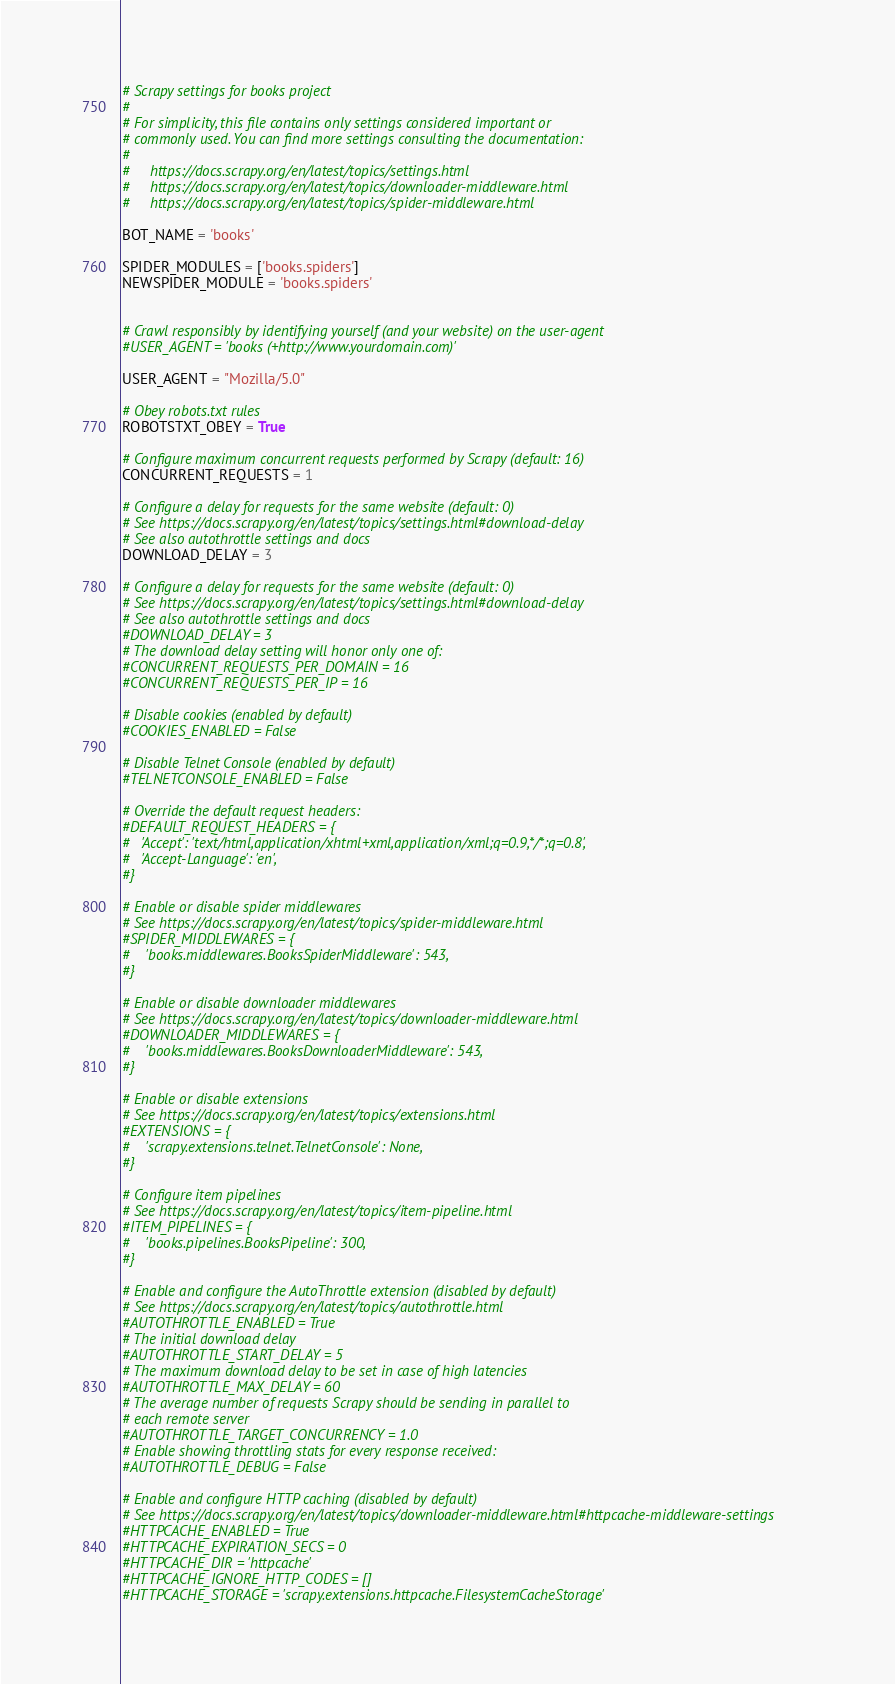<code> <loc_0><loc_0><loc_500><loc_500><_Python_># Scrapy settings for books project
#
# For simplicity, this file contains only settings considered important or
# commonly used. You can find more settings consulting the documentation:
#
#     https://docs.scrapy.org/en/latest/topics/settings.html
#     https://docs.scrapy.org/en/latest/topics/downloader-middleware.html
#     https://docs.scrapy.org/en/latest/topics/spider-middleware.html

BOT_NAME = 'books'

SPIDER_MODULES = ['books.spiders']
NEWSPIDER_MODULE = 'books.spiders'


# Crawl responsibly by identifying yourself (and your website) on the user-agent
#USER_AGENT = 'books (+http://www.yourdomain.com)'

USER_AGENT = "Mozilla/5.0"

# Obey robots.txt rules
ROBOTSTXT_OBEY = True

# Configure maximum concurrent requests performed by Scrapy (default: 16)
CONCURRENT_REQUESTS = 1

# Configure a delay for requests for the same website (default: 0)
# See https://docs.scrapy.org/en/latest/topics/settings.html#download-delay
# See also autothrottle settings and docs
DOWNLOAD_DELAY = 3

# Configure a delay for requests for the same website (default: 0)
# See https://docs.scrapy.org/en/latest/topics/settings.html#download-delay
# See also autothrottle settings and docs
#DOWNLOAD_DELAY = 3
# The download delay setting will honor only one of:
#CONCURRENT_REQUESTS_PER_DOMAIN = 16
#CONCURRENT_REQUESTS_PER_IP = 16

# Disable cookies (enabled by default)
#COOKIES_ENABLED = False

# Disable Telnet Console (enabled by default)
#TELNETCONSOLE_ENABLED = False

# Override the default request headers:
#DEFAULT_REQUEST_HEADERS = {
#   'Accept': 'text/html,application/xhtml+xml,application/xml;q=0.9,*/*;q=0.8',
#   'Accept-Language': 'en',
#}

# Enable or disable spider middlewares
# See https://docs.scrapy.org/en/latest/topics/spider-middleware.html
#SPIDER_MIDDLEWARES = {
#    'books.middlewares.BooksSpiderMiddleware': 543,
#}

# Enable or disable downloader middlewares
# See https://docs.scrapy.org/en/latest/topics/downloader-middleware.html
#DOWNLOADER_MIDDLEWARES = {
#    'books.middlewares.BooksDownloaderMiddleware': 543,
#}

# Enable or disable extensions
# See https://docs.scrapy.org/en/latest/topics/extensions.html
#EXTENSIONS = {
#    'scrapy.extensions.telnet.TelnetConsole': None,
#}

# Configure item pipelines
# See https://docs.scrapy.org/en/latest/topics/item-pipeline.html
#ITEM_PIPELINES = {
#    'books.pipelines.BooksPipeline': 300,
#}

# Enable and configure the AutoThrottle extension (disabled by default)
# See https://docs.scrapy.org/en/latest/topics/autothrottle.html
#AUTOTHROTTLE_ENABLED = True
# The initial download delay
#AUTOTHROTTLE_START_DELAY = 5
# The maximum download delay to be set in case of high latencies
#AUTOTHROTTLE_MAX_DELAY = 60
# The average number of requests Scrapy should be sending in parallel to
# each remote server
#AUTOTHROTTLE_TARGET_CONCURRENCY = 1.0
# Enable showing throttling stats for every response received:
#AUTOTHROTTLE_DEBUG = False

# Enable and configure HTTP caching (disabled by default)
# See https://docs.scrapy.org/en/latest/topics/downloader-middleware.html#httpcache-middleware-settings
#HTTPCACHE_ENABLED = True
#HTTPCACHE_EXPIRATION_SECS = 0
#HTTPCACHE_DIR = 'httpcache'
#HTTPCACHE_IGNORE_HTTP_CODES = []
#HTTPCACHE_STORAGE = 'scrapy.extensions.httpcache.FilesystemCacheStorage'
</code> 